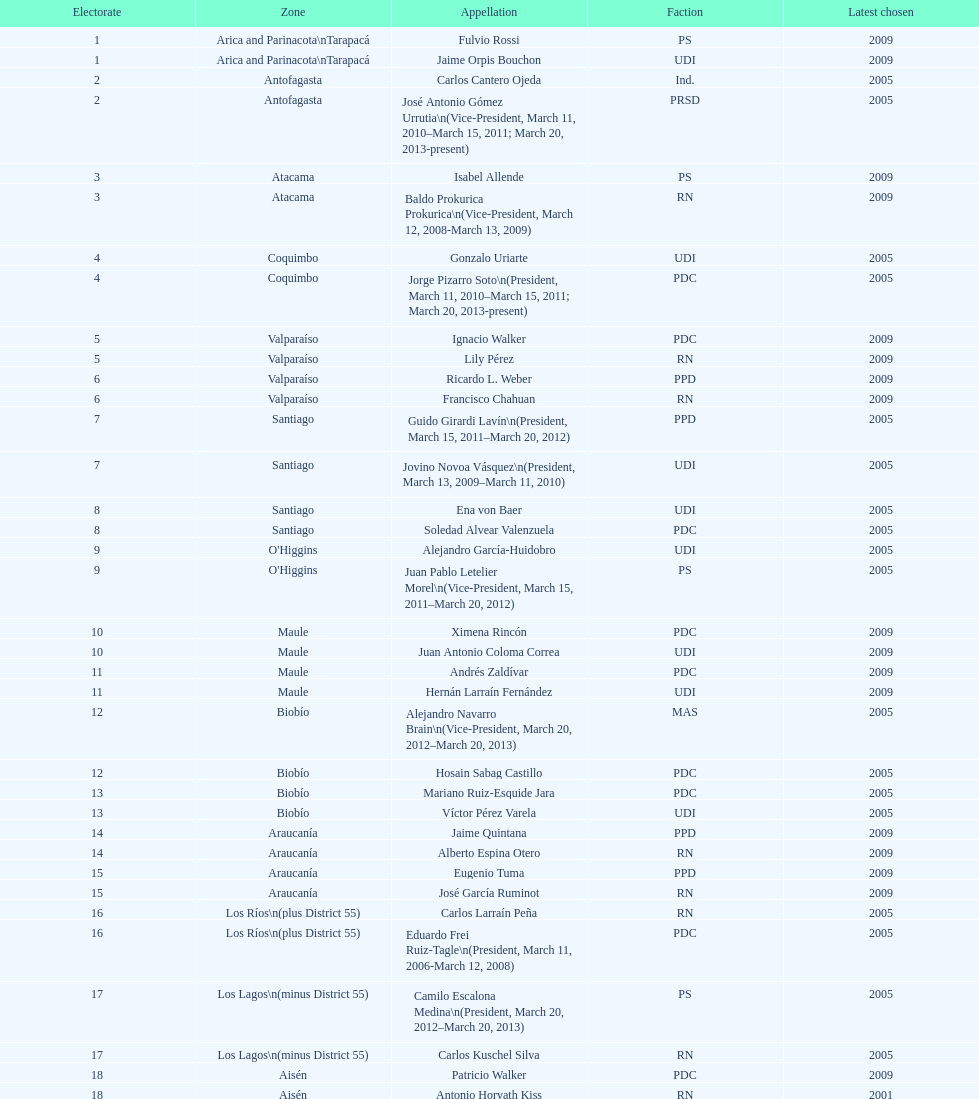What is the total number of constituencies? 19. Help me parse the entirety of this table. {'header': ['Electorate', 'Zone', 'Appellation', 'Faction', 'Latest chosen'], 'rows': [['1', 'Arica and Parinacota\\nTarapacá', 'Fulvio Rossi', 'PS', '2009'], ['1', 'Arica and Parinacota\\nTarapacá', 'Jaime Orpis Bouchon', 'UDI', '2009'], ['2', 'Antofagasta', 'Carlos Cantero Ojeda', 'Ind.', '2005'], ['2', 'Antofagasta', 'José Antonio Gómez Urrutia\\n(Vice-President, March 11, 2010–March 15, 2011; March 20, 2013-present)', 'PRSD', '2005'], ['3', 'Atacama', 'Isabel Allende', 'PS', '2009'], ['3', 'Atacama', 'Baldo Prokurica Prokurica\\n(Vice-President, March 12, 2008-March 13, 2009)', 'RN', '2009'], ['4', 'Coquimbo', 'Gonzalo Uriarte', 'UDI', '2005'], ['4', 'Coquimbo', 'Jorge Pizarro Soto\\n(President, March 11, 2010–March 15, 2011; March 20, 2013-present)', 'PDC', '2005'], ['5', 'Valparaíso', 'Ignacio Walker', 'PDC', '2009'], ['5', 'Valparaíso', 'Lily Pérez', 'RN', '2009'], ['6', 'Valparaíso', 'Ricardo L. Weber', 'PPD', '2009'], ['6', 'Valparaíso', 'Francisco Chahuan', 'RN', '2009'], ['7', 'Santiago', 'Guido Girardi Lavín\\n(President, March 15, 2011–March 20, 2012)', 'PPD', '2005'], ['7', 'Santiago', 'Jovino Novoa Vásquez\\n(President, March 13, 2009–March 11, 2010)', 'UDI', '2005'], ['8', 'Santiago', 'Ena von Baer', 'UDI', '2005'], ['8', 'Santiago', 'Soledad Alvear Valenzuela', 'PDC', '2005'], ['9', "O'Higgins", 'Alejandro García-Huidobro', 'UDI', '2005'], ['9', "O'Higgins", 'Juan Pablo Letelier Morel\\n(Vice-President, March 15, 2011–March 20, 2012)', 'PS', '2005'], ['10', 'Maule', 'Ximena Rincón', 'PDC', '2009'], ['10', 'Maule', 'Juan Antonio Coloma Correa', 'UDI', '2009'], ['11', 'Maule', 'Andrés Zaldívar', 'PDC', '2009'], ['11', 'Maule', 'Hernán Larraín Fernández', 'UDI', '2009'], ['12', 'Biobío', 'Alejandro Navarro Brain\\n(Vice-President, March 20, 2012–March 20, 2013)', 'MAS', '2005'], ['12', 'Biobío', 'Hosain Sabag Castillo', 'PDC', '2005'], ['13', 'Biobío', 'Mariano Ruiz-Esquide Jara', 'PDC', '2005'], ['13', 'Biobío', 'Víctor Pérez Varela', 'UDI', '2005'], ['14', 'Araucanía', 'Jaime Quintana', 'PPD', '2009'], ['14', 'Araucanía', 'Alberto Espina Otero', 'RN', '2009'], ['15', 'Araucanía', 'Eugenio Tuma', 'PPD', '2009'], ['15', 'Araucanía', 'José García Ruminot', 'RN', '2009'], ['16', 'Los Ríos\\n(plus District 55)', 'Carlos Larraín Peña', 'RN', '2005'], ['16', 'Los Ríos\\n(plus District 55)', 'Eduardo Frei Ruiz-Tagle\\n(President, March 11, 2006-March 12, 2008)', 'PDC', '2005'], ['17', 'Los Lagos\\n(minus District 55)', 'Camilo Escalona Medina\\n(President, March 20, 2012–March 20, 2013)', 'PS', '2005'], ['17', 'Los Lagos\\n(minus District 55)', 'Carlos Kuschel Silva', 'RN', '2005'], ['18', 'Aisén', 'Patricio Walker', 'PDC', '2009'], ['18', 'Aisén', 'Antonio Horvath Kiss', 'RN', '2001'], ['19', 'Magallanes', 'Carlos Bianchi Chelech\\n(Vice-President, March 13, 2009–March 11, 2010)', 'Ind.', '2005'], ['19', 'Magallanes', 'Pedro Muñoz Aburto', 'PS', '2005']]} 